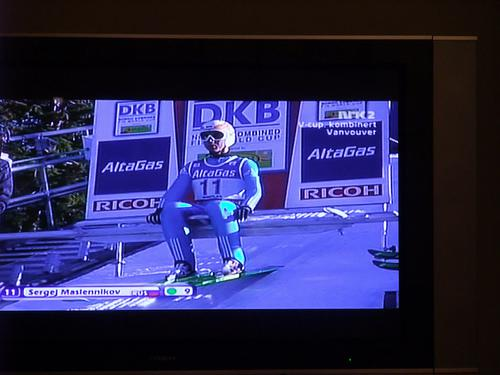Question: where was the picture taken?
Choices:
A. Near a resort.
B. Near a hotel.
C. At a ski jump competition.
D. Near a school.
Answer with the letter. Answer: C Question: what are on the skiers feet?
Choices:
A. Flippers.
B. Ski boots and skis.
C. Bunny slippers.
D. Combat boots.
Answer with the letter. Answer: B Question: what country is the skier representing?
Choices:
A. China.
B. Russia.
C. England.
D. South Africa.
Answer with the letter. Answer: B Question: what letters are featured above the skier?
Choices:
A. Crl.
B. DKB.
C. Kro.
D. Ynh.
Answer with the letter. Answer: B 